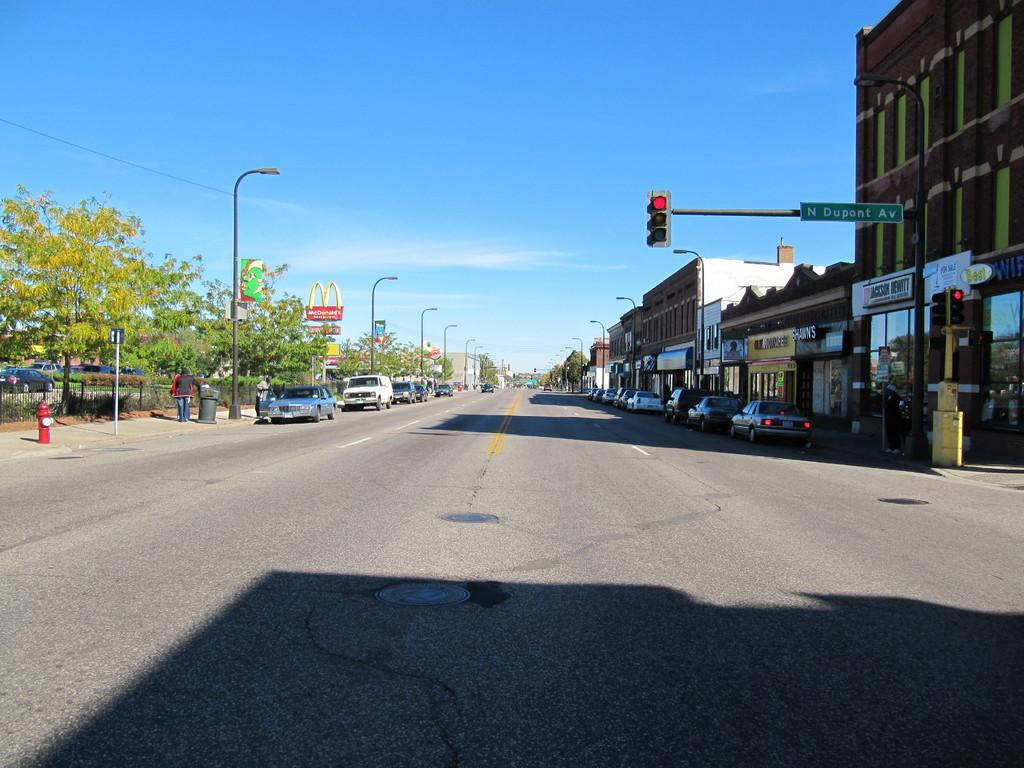Provide a one-sentence caption for the provided image. Shawn's is to the left of Jackson Hewitt. 